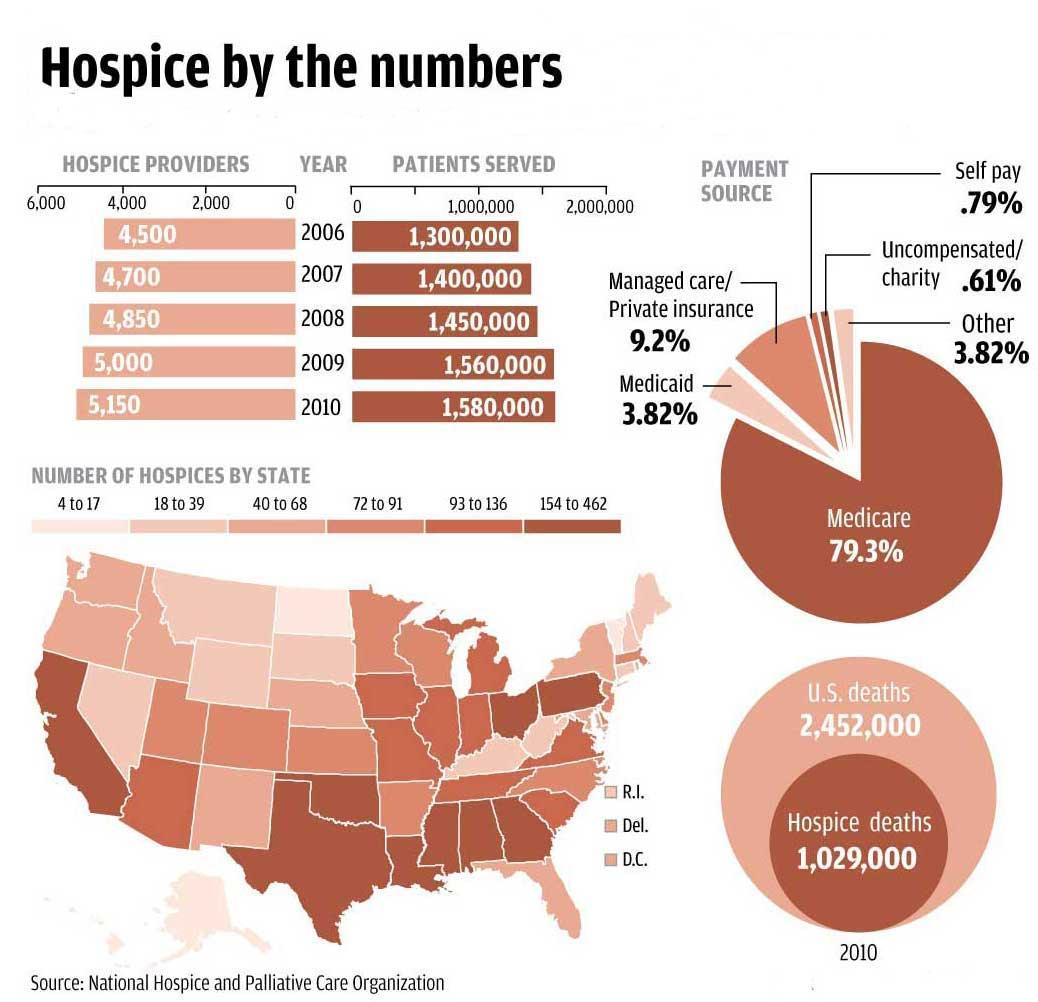Which year shows higher number of hospice providers 2008, 2009, 2007 ?
Answer the question with a short phrase. 2009 Which year shows the highest number of patients served 2006, 2010, or 2008 ? 2010 What is the total percentage from the payment sources Self pay , Uncompensated charity and other? 5.22% What is difference in number of patients served in 2010 and 2006 280,000 What is the number of hospice providers in the year prior to 2008? 4,700 Calculate the aggregate of payment sources contributed by Medicaid and Managed Care 13.02% What is the number of deaths due to other reasons or factors in US? 1,423,000 Calculate the difference between Hospice providers in 2010 and 2006? 650 What is the number of patients served in the year after 2007 ? 1,450,000 